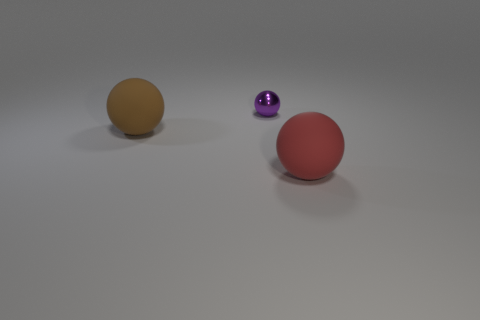There is a big thing that is on the right side of the small purple ball; what shape is it?
Your answer should be compact. Sphere. The large sphere that is behind the matte ball that is on the right side of the large brown thing is what color?
Offer a terse response. Brown. The other rubber thing that is the same shape as the large brown matte object is what color?
Your answer should be very brief. Red. How many big rubber things are the same color as the small object?
Offer a terse response. 0. There is a small metallic thing; does it have the same color as the big sphere that is behind the big red thing?
Give a very brief answer. No. There is a object that is right of the large brown rubber thing and in front of the purple ball; what is its shape?
Offer a very short reply. Sphere. What is the material of the big sphere that is right of the small metal sphere left of the object that is on the right side of the tiny metallic ball?
Your answer should be very brief. Rubber. Is the number of matte spheres that are to the left of the tiny purple metallic object greater than the number of brown objects right of the red rubber thing?
Your response must be concise. Yes. How many red balls are the same material as the brown object?
Give a very brief answer. 1. There is a object right of the purple thing; does it have the same shape as the brown rubber object left of the small shiny sphere?
Your answer should be very brief. Yes. 